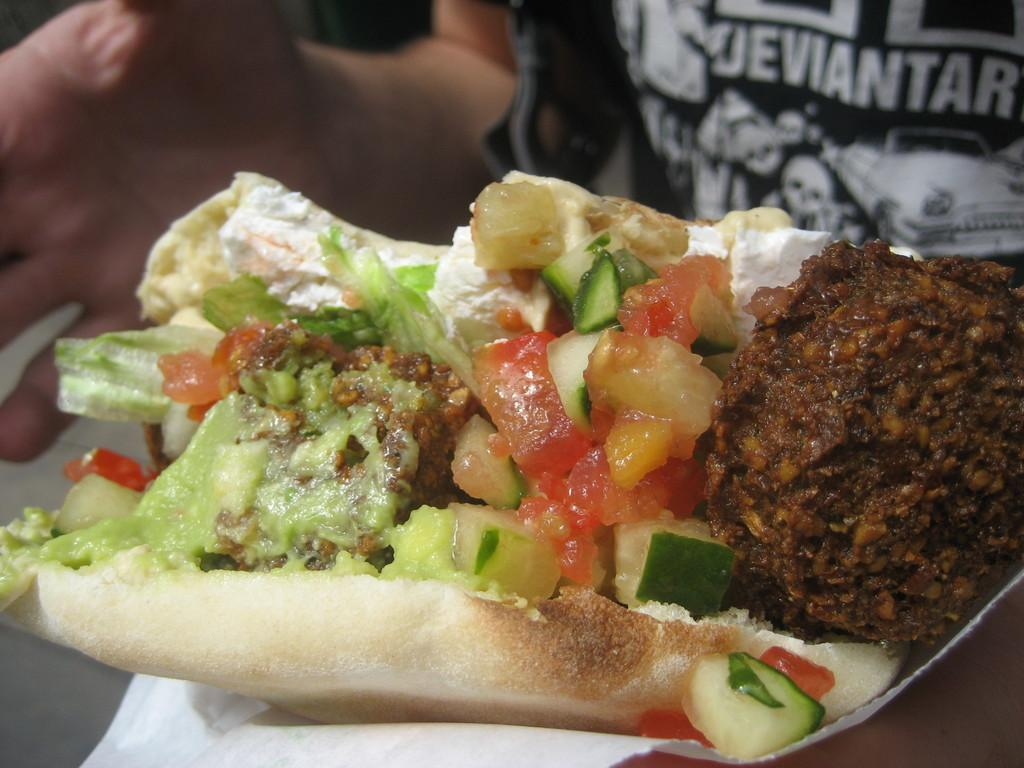What is the main subject of the image? There is a person in the image. What is the person wearing? The person is wearing a black t-shirt. What is the person holding in the image? The person is holding food. How is the person holding the food? The person is using tissue to hold the food. What can be seen on the t-shirt? There is text on the t-shirt. What type of rose can be seen growing on the person's t-shirt in the image? There is no rose present on the person's t-shirt in the image. What nation is represented by the text on the person's t-shirt in the image? There is no information about a nation represented by the text on the person's t-shirt in the image. 